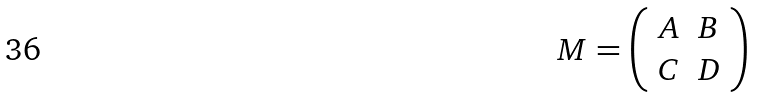Convert formula to latex. <formula><loc_0><loc_0><loc_500><loc_500>M = \left ( \begin{array} { c c } { A } & { B } \\ { C } & { D } \end{array} \right )</formula> 